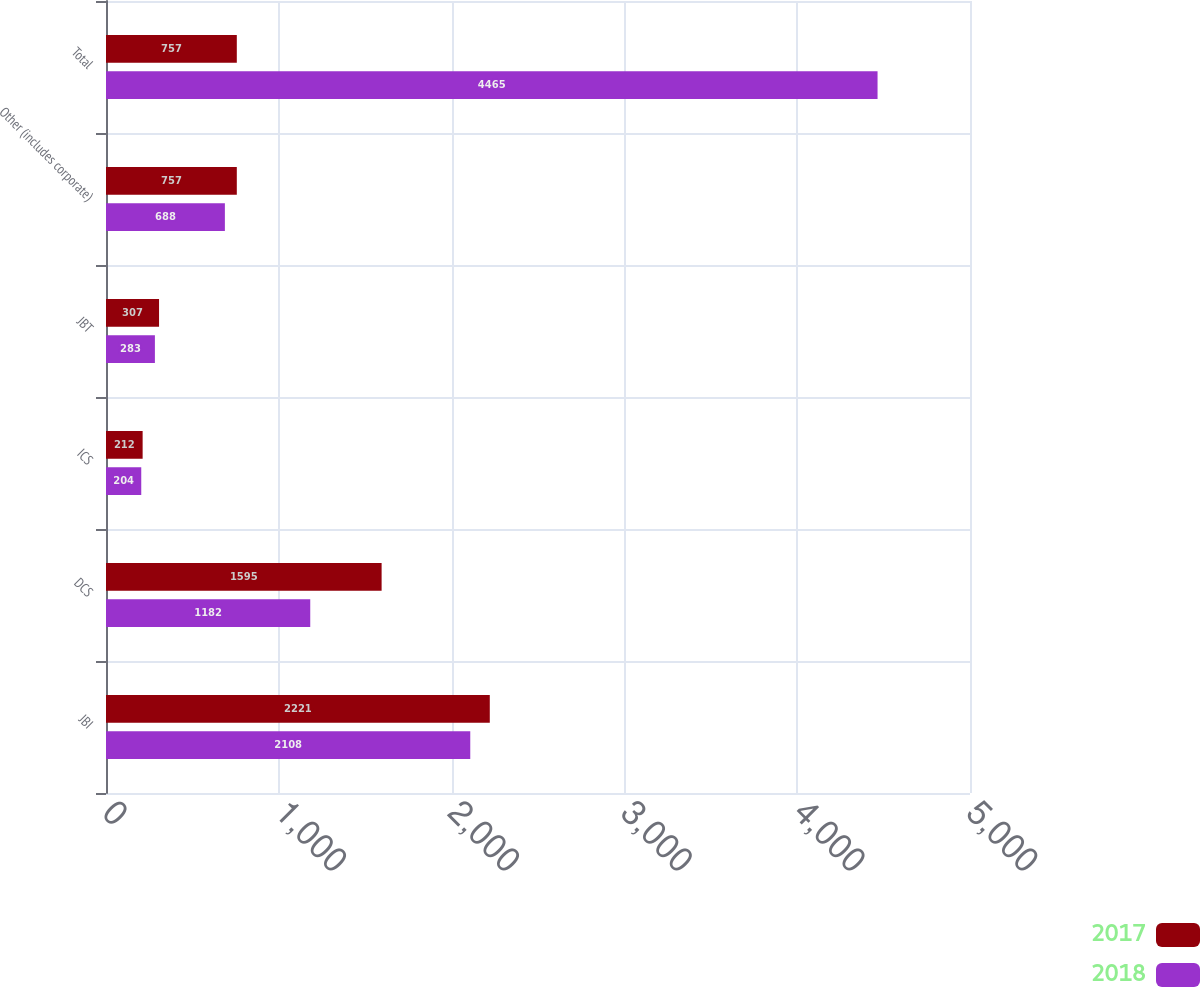<chart> <loc_0><loc_0><loc_500><loc_500><stacked_bar_chart><ecel><fcel>JBI<fcel>DCS<fcel>ICS<fcel>JBT<fcel>Other (includes corporate)<fcel>Total<nl><fcel>2017<fcel>2221<fcel>1595<fcel>212<fcel>307<fcel>757<fcel>757<nl><fcel>2018<fcel>2108<fcel>1182<fcel>204<fcel>283<fcel>688<fcel>4465<nl></chart> 